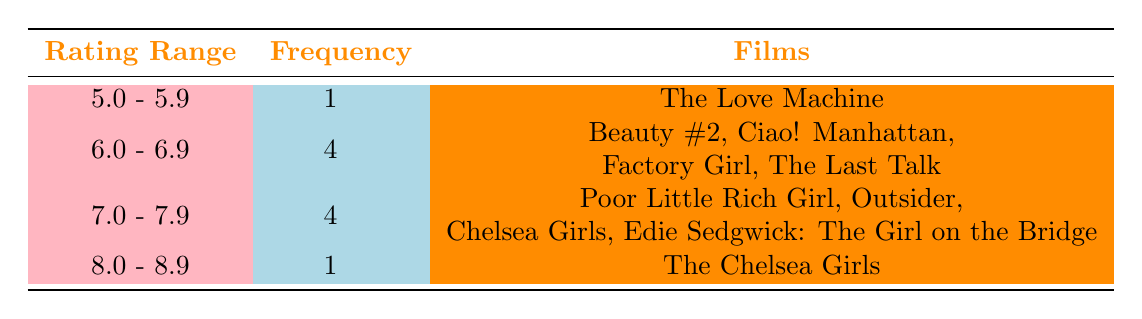What is the frequency of films with viewer ratings between 6.0 and 6.9? There are 4 films that fall within the rating range of 6.0 - 6.9 according to the table. These films are Beauty #2, Ciao! Manhattan, Factory Girl, and The Last Talk.
Answer: 4 Which film has the highest viewer rating among those listed? The highest viewer rating among the films listed is 8.0, which corresponds to the film The Chelsea Girls.
Answer: The Chelsea Girls How many films received a rating of 7.0 or higher? There are 5 films that received a rating of 7.0 or higher: Poor Little Rich Girl, Outsider, Chelsea Girls, and Edie Sedgwick: The Girl on the Bridge (4 films in the 7.0 - 7.9 range and 1 film in the 8.0 - 8.9 range).
Answer: 5 Are there any films with a viewer rating below 6.0? Yes, there is one film, The Love Machine, with a viewer rating below 6.0.
Answer: Yes Calculate the average viewer rating of all the films listed in the table. To find the average, first sum the viewer ratings: 7.5 + 6.6 + 6.2 + 8.0 + 7.0 + 7.8 + 5.5 + 6.9 + 7.1 + 6.0 = 69.6. There are 10 films, so the average rating is 69.6 / 10 = 6.96.
Answer: 6.96 How many films were rated 7.5 or higher? There are 5 films rated 7.5 or higher: Chelsea Girls, Edie Sedgwick: The Girl on the Bridge, and The Chelsea Girls (which has a rating of 8.0).
Answer: 5 